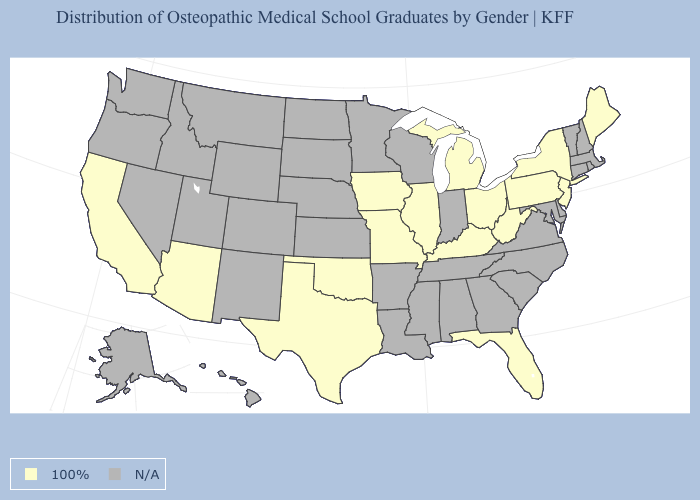What is the highest value in the USA?
Be succinct. 100%. What is the highest value in the USA?
Concise answer only. 100%. What is the value of New Jersey?
Quick response, please. 100%. What is the value of California?
Answer briefly. 100%. Among the states that border Delaware , which have the highest value?
Be succinct. New Jersey, Pennsylvania. What is the lowest value in the USA?
Quick response, please. 100%. Name the states that have a value in the range N/A?
Concise answer only. Alabama, Alaska, Arkansas, Colorado, Connecticut, Delaware, Georgia, Hawaii, Idaho, Indiana, Kansas, Louisiana, Maryland, Massachusetts, Minnesota, Mississippi, Montana, Nebraska, Nevada, New Hampshire, New Mexico, North Carolina, North Dakota, Oregon, Rhode Island, South Carolina, South Dakota, Tennessee, Utah, Vermont, Virginia, Washington, Wisconsin, Wyoming. What is the lowest value in states that border Virginia?
Be succinct. 100%. 